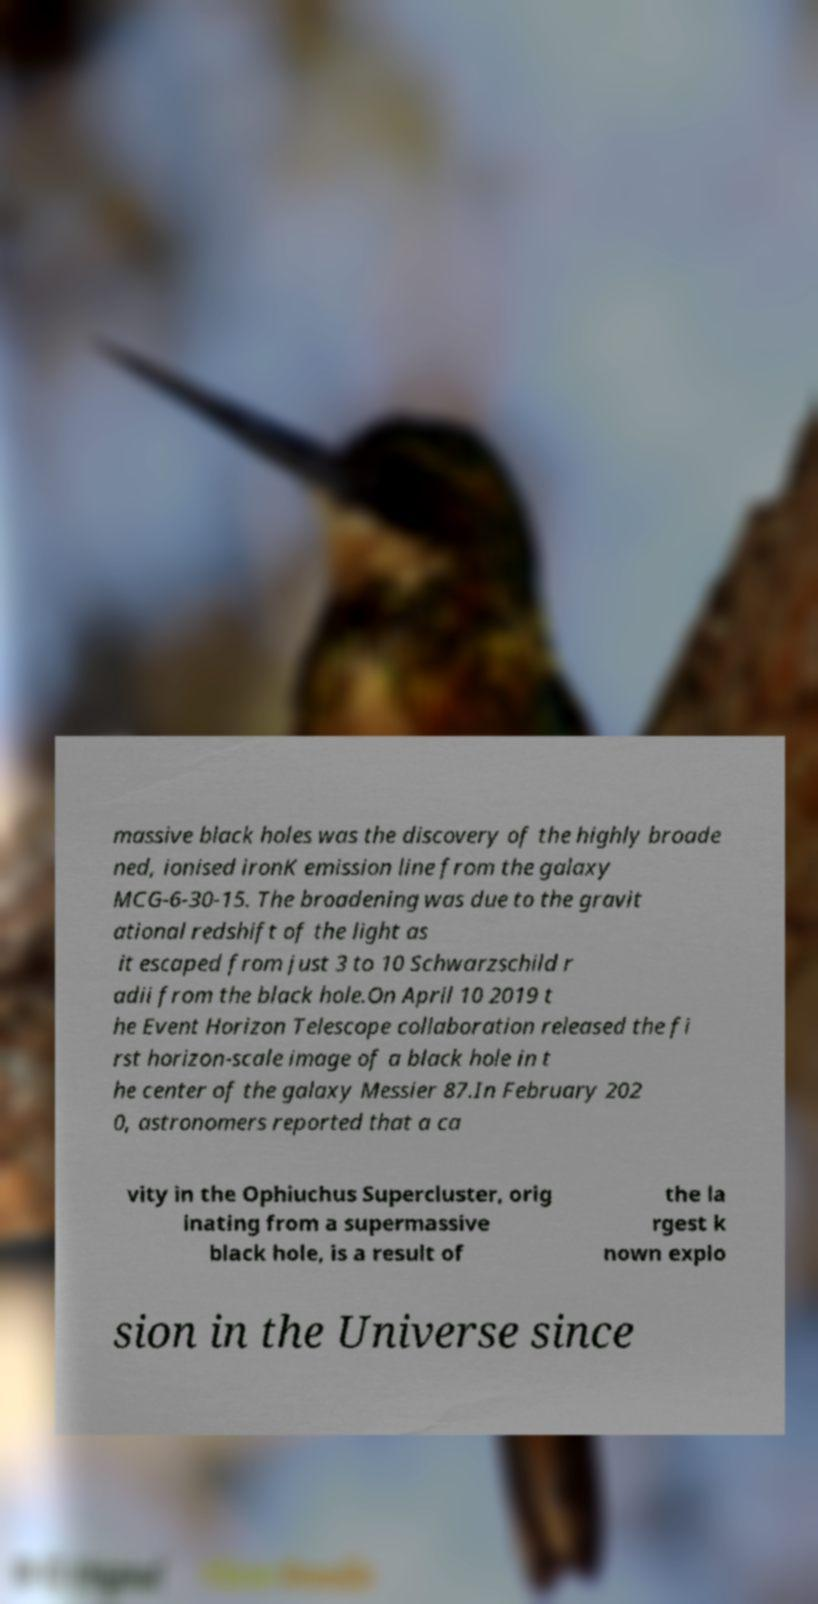Please identify and transcribe the text found in this image. massive black holes was the discovery of the highly broade ned, ionised ironK emission line from the galaxy MCG-6-30-15. The broadening was due to the gravit ational redshift of the light as it escaped from just 3 to 10 Schwarzschild r adii from the black hole.On April 10 2019 t he Event Horizon Telescope collaboration released the fi rst horizon-scale image of a black hole in t he center of the galaxy Messier 87.In February 202 0, astronomers reported that a ca vity in the Ophiuchus Supercluster, orig inating from a supermassive black hole, is a result of the la rgest k nown explo sion in the Universe since 